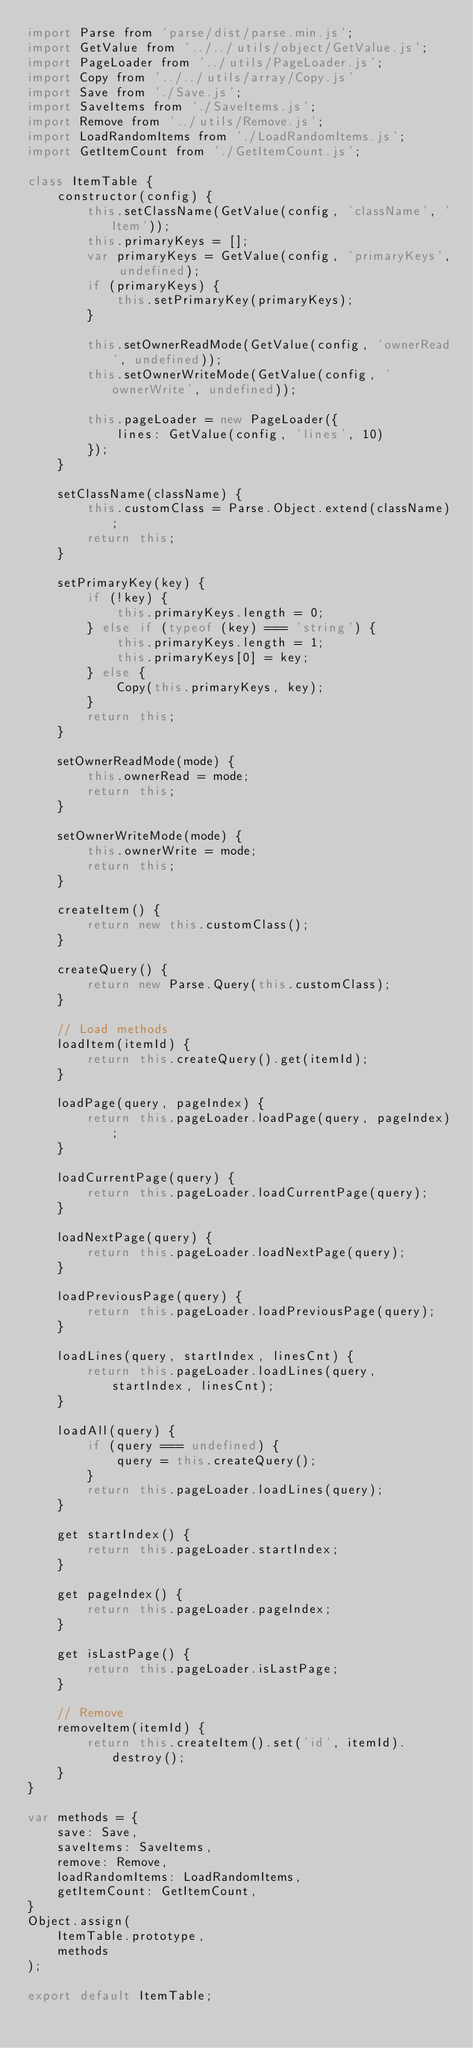<code> <loc_0><loc_0><loc_500><loc_500><_JavaScript_>import Parse from 'parse/dist/parse.min.js';
import GetValue from '../../utils/object/GetValue.js';
import PageLoader from '../utils/PageLoader.js';
import Copy from '../../utils/array/Copy.js'
import Save from './Save.js';
import SaveItems from './SaveItems.js';
import Remove from '../utils/Remove.js';
import LoadRandomItems from './LoadRandomItems.js';
import GetItemCount from './GetItemCount.js';

class ItemTable {
    constructor(config) {
        this.setClassName(GetValue(config, 'className', 'Item'));
        this.primaryKeys = [];
        var primaryKeys = GetValue(config, 'primaryKeys', undefined);
        if (primaryKeys) {
            this.setPrimaryKey(primaryKeys);
        }

        this.setOwnerReadMode(GetValue(config, 'ownerRead', undefined));
        this.setOwnerWriteMode(GetValue(config, 'ownerWrite', undefined));

        this.pageLoader = new PageLoader({
            lines: GetValue(config, 'lines', 10)
        });
    }

    setClassName(className) {
        this.customClass = Parse.Object.extend(className);
        return this;
    }

    setPrimaryKey(key) {
        if (!key) {
            this.primaryKeys.length = 0;
        } else if (typeof (key) === 'string') {
            this.primaryKeys.length = 1;
            this.primaryKeys[0] = key;
        } else {
            Copy(this.primaryKeys, key);
        }
        return this;
    }

    setOwnerReadMode(mode) {
        this.ownerRead = mode;
        return this;
    }

    setOwnerWriteMode(mode) {
        this.ownerWrite = mode;
        return this;
    }

    createItem() {
        return new this.customClass();
    }

    createQuery() {
        return new Parse.Query(this.customClass);
    }

    // Load methods
    loadItem(itemId) {
        return this.createQuery().get(itemId);
    }

    loadPage(query, pageIndex) {
        return this.pageLoader.loadPage(query, pageIndex);
    }

    loadCurrentPage(query) {
        return this.pageLoader.loadCurrentPage(query);
    }

    loadNextPage(query) {
        return this.pageLoader.loadNextPage(query);
    }

    loadPreviousPage(query) {
        return this.pageLoader.loadPreviousPage(query);
    }

    loadLines(query, startIndex, linesCnt) {
        return this.pageLoader.loadLines(query, startIndex, linesCnt);
    }

    loadAll(query) {
        if (query === undefined) {
            query = this.createQuery();
        }
        return this.pageLoader.loadLines(query);
    }

    get startIndex() {
        return this.pageLoader.startIndex;
    }

    get pageIndex() {
        return this.pageLoader.pageIndex;
    }

    get isLastPage() {
        return this.pageLoader.isLastPage;
    }

    // Remove
    removeItem(itemId) {
        return this.createItem().set('id', itemId).destroy();
    }
}

var methods = {
    save: Save,
    saveItems: SaveItems,
    remove: Remove,
    loadRandomItems: LoadRandomItems,
    getItemCount: GetItemCount,
}
Object.assign(
    ItemTable.prototype,
    methods
);

export default ItemTable;</code> 